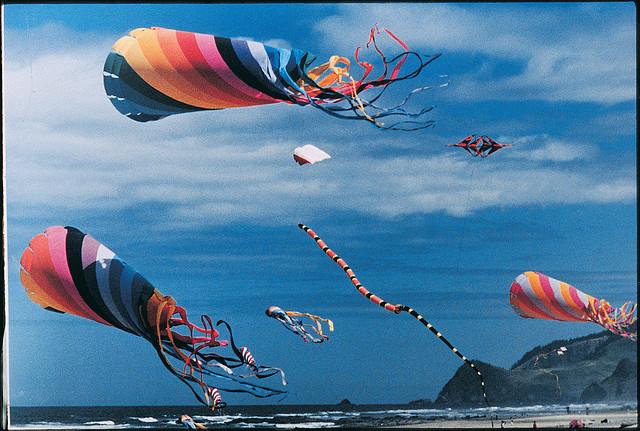What are in the air?
Write a very short answer. Kites. How many kites are flying?
Give a very brief answer. 6. Are all of the kites the same?
Short answer required. No. 